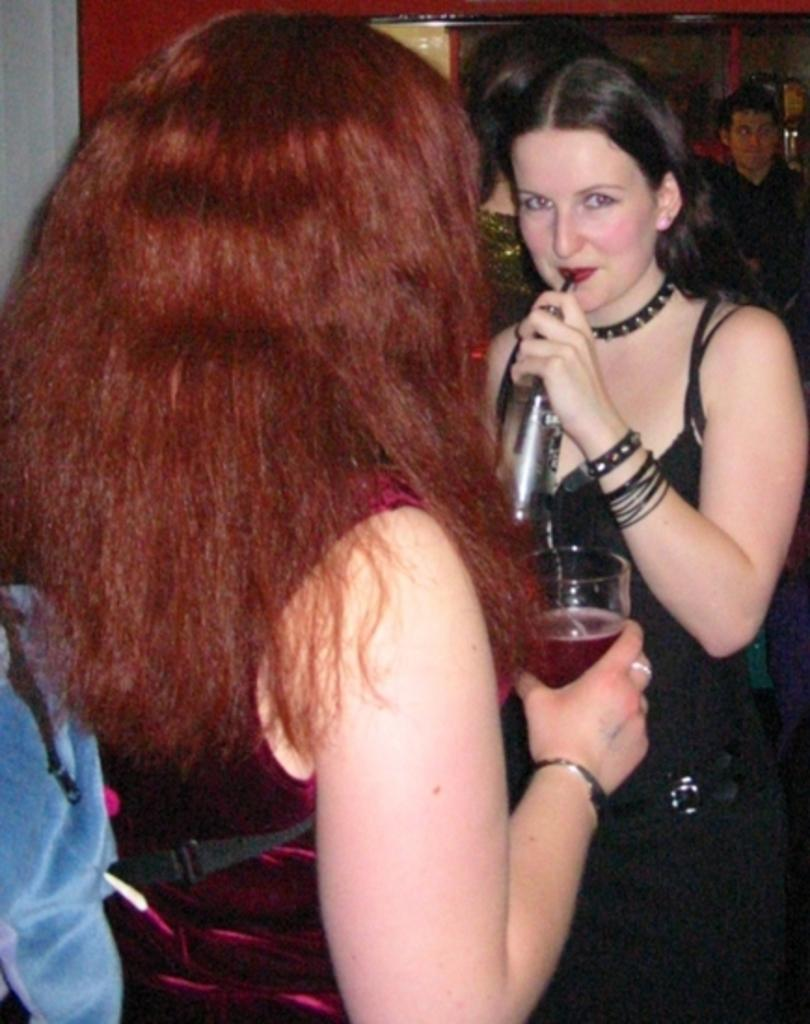How many people are in the image? There are people in the image, but the exact number is not specified. What are the two people holding in the image? Two people are holding objects in the image, but the specific objects are not described. What can be seen behind the people in the image? There is a wall visible in the image. What type of popcorn is being used for the magic trick in the image? There is no popcorn or magic trick present in the image. How is the chain attached to the wall in the image? There is no chain visible in the image. 